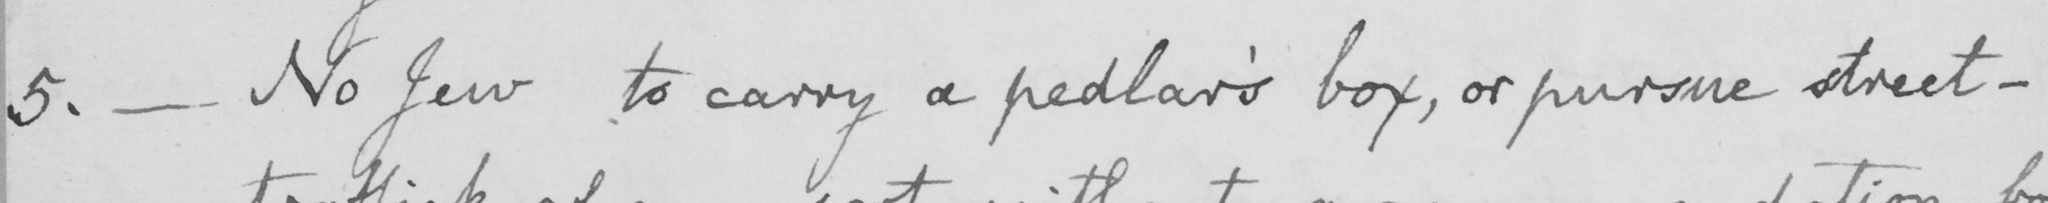Can you read and transcribe this handwriting? 5 .  _  No Jew to carry a pedlar ' s box , or pursue street- 